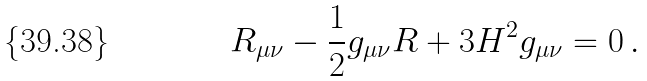Convert formula to latex. <formula><loc_0><loc_0><loc_500><loc_500>R _ { \mu \nu } - \frac { 1 } { 2 } g _ { \mu \nu } R + 3 H ^ { 2 } g _ { \mu \nu } = 0 \, .</formula> 